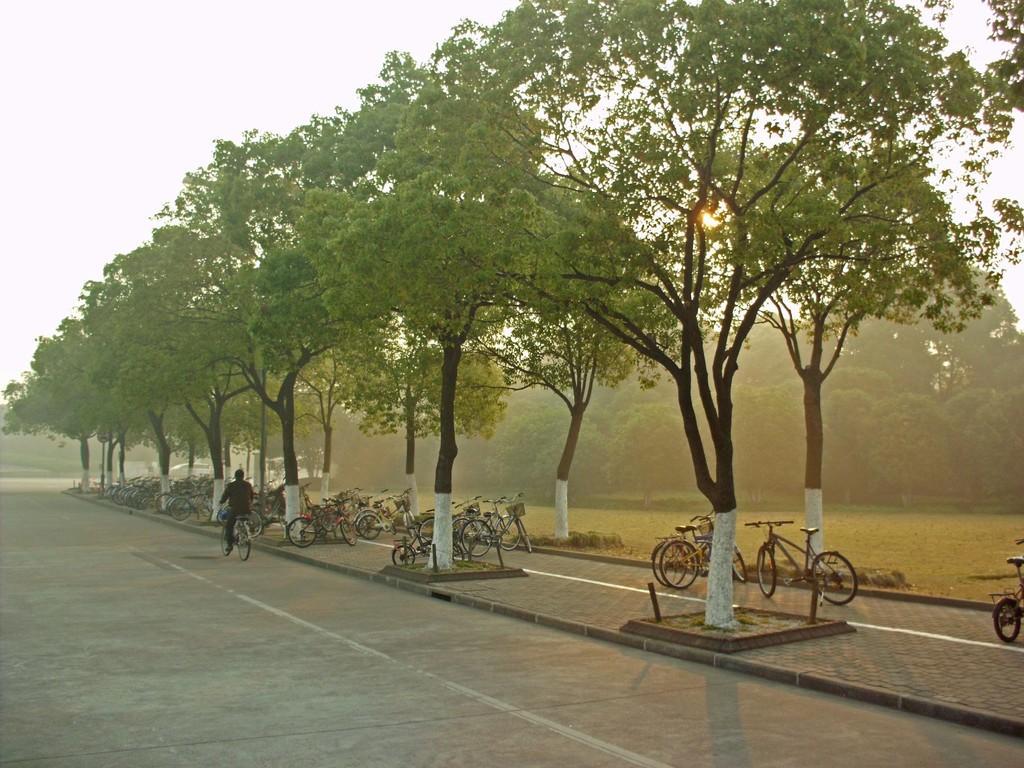Describe this image in one or two sentences. This picture is taken from the outside of the city. In this image, on the right side, we can see some trees and bicycles which are placed on the footpath. On the right side, we can see some trees and plants. In the middle of the image, we can see a man riding a bicycle. In the background, we can see some trees, plants, bicycles. At the top, we can see a sky, at the bottom, we can see a grass, road and a footpath. 